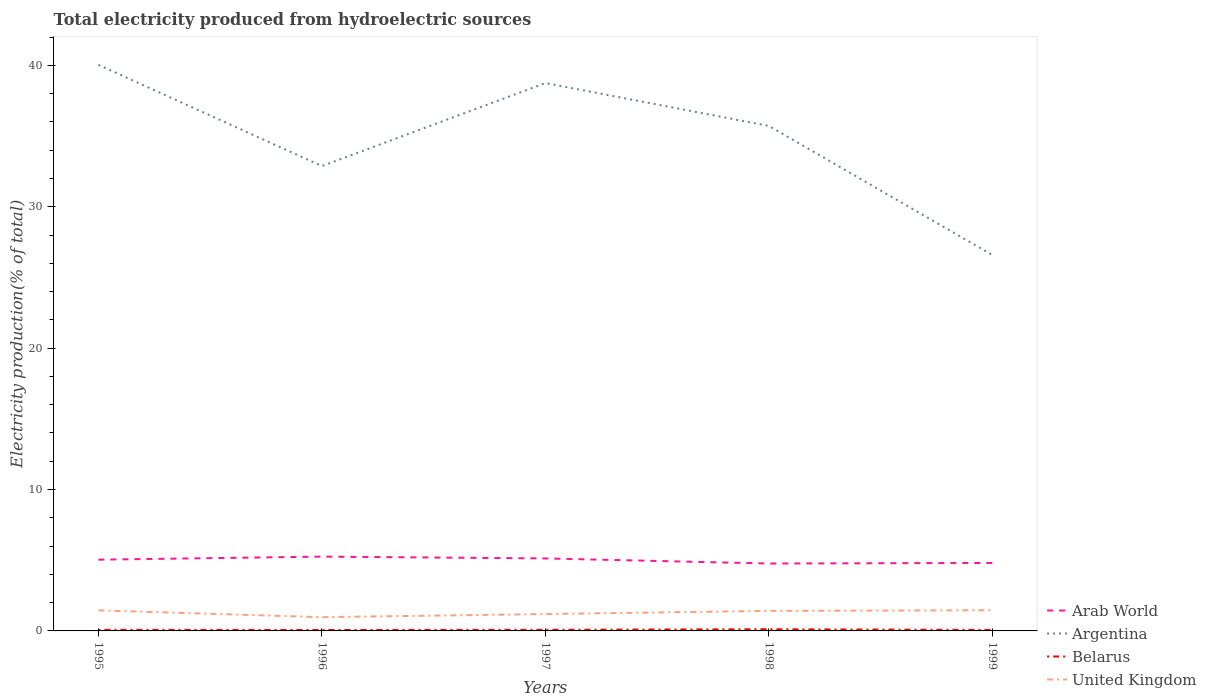How many different coloured lines are there?
Your response must be concise. 4. Across all years, what is the maximum total electricity produced in Arab World?
Your response must be concise. 4.77. What is the total total electricity produced in United Kingdom in the graph?
Your response must be concise. -0.45. What is the difference between the highest and the second highest total electricity produced in Belarus?
Provide a succinct answer. 0.05. What is the difference between the highest and the lowest total electricity produced in Belarus?
Provide a succinct answer. 1. How many lines are there?
Provide a succinct answer. 4. What is the difference between two consecutive major ticks on the Y-axis?
Your answer should be compact. 10. Are the values on the major ticks of Y-axis written in scientific E-notation?
Your answer should be compact. No. Where does the legend appear in the graph?
Provide a short and direct response. Bottom right. How are the legend labels stacked?
Offer a terse response. Vertical. What is the title of the graph?
Offer a terse response. Total electricity produced from hydroelectric sources. What is the label or title of the X-axis?
Your answer should be compact. Years. What is the Electricity production(% of total) in Arab World in 1995?
Your answer should be very brief. 5.04. What is the Electricity production(% of total) of Argentina in 1995?
Provide a succinct answer. 40.04. What is the Electricity production(% of total) of Belarus in 1995?
Provide a short and direct response. 0.08. What is the Electricity production(% of total) of United Kingdom in 1995?
Your response must be concise. 1.46. What is the Electricity production(% of total) of Arab World in 1996?
Make the answer very short. 5.26. What is the Electricity production(% of total) of Argentina in 1996?
Give a very brief answer. 32.88. What is the Electricity production(% of total) of Belarus in 1996?
Provide a short and direct response. 0.07. What is the Electricity production(% of total) of United Kingdom in 1996?
Keep it short and to the point. 0.97. What is the Electricity production(% of total) of Arab World in 1997?
Your response must be concise. 5.13. What is the Electricity production(% of total) in Argentina in 1997?
Make the answer very short. 38.75. What is the Electricity production(% of total) in Belarus in 1997?
Ensure brevity in your answer.  0.08. What is the Electricity production(% of total) in United Kingdom in 1997?
Keep it short and to the point. 1.19. What is the Electricity production(% of total) of Arab World in 1998?
Ensure brevity in your answer.  4.77. What is the Electricity production(% of total) in Argentina in 1998?
Provide a short and direct response. 35.72. What is the Electricity production(% of total) in Belarus in 1998?
Offer a very short reply. 0.12. What is the Electricity production(% of total) in United Kingdom in 1998?
Give a very brief answer. 1.42. What is the Electricity production(% of total) of Arab World in 1999?
Offer a terse response. 4.81. What is the Electricity production(% of total) of Argentina in 1999?
Offer a terse response. 26.58. What is the Electricity production(% of total) of Belarus in 1999?
Ensure brevity in your answer.  0.07. What is the Electricity production(% of total) in United Kingdom in 1999?
Your answer should be compact. 1.46. Across all years, what is the maximum Electricity production(% of total) in Arab World?
Give a very brief answer. 5.26. Across all years, what is the maximum Electricity production(% of total) of Argentina?
Your response must be concise. 40.04. Across all years, what is the maximum Electricity production(% of total) of Belarus?
Give a very brief answer. 0.12. Across all years, what is the maximum Electricity production(% of total) of United Kingdom?
Give a very brief answer. 1.46. Across all years, what is the minimum Electricity production(% of total) of Arab World?
Your answer should be very brief. 4.77. Across all years, what is the minimum Electricity production(% of total) in Argentina?
Ensure brevity in your answer.  26.58. Across all years, what is the minimum Electricity production(% of total) of Belarus?
Your answer should be compact. 0.07. Across all years, what is the minimum Electricity production(% of total) in United Kingdom?
Ensure brevity in your answer.  0.97. What is the total Electricity production(% of total) of Arab World in the graph?
Provide a short and direct response. 25. What is the total Electricity production(% of total) in Argentina in the graph?
Your response must be concise. 173.97. What is the total Electricity production(% of total) of Belarus in the graph?
Ensure brevity in your answer.  0.42. What is the total Electricity production(% of total) of United Kingdom in the graph?
Provide a succinct answer. 6.5. What is the difference between the Electricity production(% of total) of Arab World in 1995 and that in 1996?
Offer a very short reply. -0.22. What is the difference between the Electricity production(% of total) in Argentina in 1995 and that in 1996?
Your response must be concise. 7.16. What is the difference between the Electricity production(% of total) in Belarus in 1995 and that in 1996?
Provide a short and direct response. 0.01. What is the difference between the Electricity production(% of total) in United Kingdom in 1995 and that in 1996?
Your response must be concise. 0.48. What is the difference between the Electricity production(% of total) in Arab World in 1995 and that in 1997?
Make the answer very short. -0.09. What is the difference between the Electricity production(% of total) in Argentina in 1995 and that in 1997?
Ensure brevity in your answer.  1.29. What is the difference between the Electricity production(% of total) of Belarus in 1995 and that in 1997?
Provide a succinct answer. -0. What is the difference between the Electricity production(% of total) of United Kingdom in 1995 and that in 1997?
Ensure brevity in your answer.  0.26. What is the difference between the Electricity production(% of total) in Arab World in 1995 and that in 1998?
Offer a terse response. 0.27. What is the difference between the Electricity production(% of total) of Argentina in 1995 and that in 1998?
Your response must be concise. 4.32. What is the difference between the Electricity production(% of total) of Belarus in 1995 and that in 1998?
Provide a short and direct response. -0.04. What is the difference between the Electricity production(% of total) in United Kingdom in 1995 and that in 1998?
Make the answer very short. 0.04. What is the difference between the Electricity production(% of total) of Arab World in 1995 and that in 1999?
Make the answer very short. 0.23. What is the difference between the Electricity production(% of total) of Argentina in 1995 and that in 1999?
Provide a short and direct response. 13.45. What is the difference between the Electricity production(% of total) in Belarus in 1995 and that in 1999?
Give a very brief answer. 0.01. What is the difference between the Electricity production(% of total) of United Kingdom in 1995 and that in 1999?
Provide a succinct answer. -0.01. What is the difference between the Electricity production(% of total) of Arab World in 1996 and that in 1997?
Provide a succinct answer. 0.13. What is the difference between the Electricity production(% of total) of Argentina in 1996 and that in 1997?
Offer a very short reply. -5.87. What is the difference between the Electricity production(% of total) of Belarus in 1996 and that in 1997?
Make the answer very short. -0.01. What is the difference between the Electricity production(% of total) of United Kingdom in 1996 and that in 1997?
Your response must be concise. -0.22. What is the difference between the Electricity production(% of total) of Arab World in 1996 and that in 1998?
Provide a succinct answer. 0.49. What is the difference between the Electricity production(% of total) of Argentina in 1996 and that in 1998?
Keep it short and to the point. -2.84. What is the difference between the Electricity production(% of total) of Belarus in 1996 and that in 1998?
Provide a succinct answer. -0.05. What is the difference between the Electricity production(% of total) of United Kingdom in 1996 and that in 1998?
Your response must be concise. -0.45. What is the difference between the Electricity production(% of total) of Arab World in 1996 and that in 1999?
Your answer should be compact. 0.45. What is the difference between the Electricity production(% of total) of Argentina in 1996 and that in 1999?
Offer a terse response. 6.29. What is the difference between the Electricity production(% of total) of Belarus in 1996 and that in 1999?
Your response must be concise. -0. What is the difference between the Electricity production(% of total) in United Kingdom in 1996 and that in 1999?
Keep it short and to the point. -0.49. What is the difference between the Electricity production(% of total) in Arab World in 1997 and that in 1998?
Offer a very short reply. 0.36. What is the difference between the Electricity production(% of total) in Argentina in 1997 and that in 1998?
Your answer should be very brief. 3.03. What is the difference between the Electricity production(% of total) of Belarus in 1997 and that in 1998?
Ensure brevity in your answer.  -0.04. What is the difference between the Electricity production(% of total) in United Kingdom in 1997 and that in 1998?
Offer a terse response. -0.22. What is the difference between the Electricity production(% of total) of Arab World in 1997 and that in 1999?
Provide a short and direct response. 0.32. What is the difference between the Electricity production(% of total) of Argentina in 1997 and that in 1999?
Ensure brevity in your answer.  12.16. What is the difference between the Electricity production(% of total) of Belarus in 1997 and that in 1999?
Provide a short and direct response. 0.01. What is the difference between the Electricity production(% of total) in United Kingdom in 1997 and that in 1999?
Keep it short and to the point. -0.27. What is the difference between the Electricity production(% of total) in Arab World in 1998 and that in 1999?
Your response must be concise. -0.04. What is the difference between the Electricity production(% of total) in Argentina in 1998 and that in 1999?
Offer a terse response. 9.13. What is the difference between the Electricity production(% of total) of Belarus in 1998 and that in 1999?
Offer a terse response. 0.05. What is the difference between the Electricity production(% of total) in United Kingdom in 1998 and that in 1999?
Your answer should be very brief. -0.04. What is the difference between the Electricity production(% of total) in Arab World in 1995 and the Electricity production(% of total) in Argentina in 1996?
Ensure brevity in your answer.  -27.84. What is the difference between the Electricity production(% of total) of Arab World in 1995 and the Electricity production(% of total) of Belarus in 1996?
Offer a terse response. 4.97. What is the difference between the Electricity production(% of total) of Arab World in 1995 and the Electricity production(% of total) of United Kingdom in 1996?
Provide a succinct answer. 4.07. What is the difference between the Electricity production(% of total) of Argentina in 1995 and the Electricity production(% of total) of Belarus in 1996?
Give a very brief answer. 39.97. What is the difference between the Electricity production(% of total) in Argentina in 1995 and the Electricity production(% of total) in United Kingdom in 1996?
Your answer should be very brief. 39.07. What is the difference between the Electricity production(% of total) in Belarus in 1995 and the Electricity production(% of total) in United Kingdom in 1996?
Offer a very short reply. -0.89. What is the difference between the Electricity production(% of total) of Arab World in 1995 and the Electricity production(% of total) of Argentina in 1997?
Provide a succinct answer. -33.71. What is the difference between the Electricity production(% of total) in Arab World in 1995 and the Electricity production(% of total) in Belarus in 1997?
Your answer should be very brief. 4.96. What is the difference between the Electricity production(% of total) of Arab World in 1995 and the Electricity production(% of total) of United Kingdom in 1997?
Give a very brief answer. 3.85. What is the difference between the Electricity production(% of total) of Argentina in 1995 and the Electricity production(% of total) of Belarus in 1997?
Your answer should be very brief. 39.96. What is the difference between the Electricity production(% of total) in Argentina in 1995 and the Electricity production(% of total) in United Kingdom in 1997?
Provide a short and direct response. 38.84. What is the difference between the Electricity production(% of total) of Belarus in 1995 and the Electricity production(% of total) of United Kingdom in 1997?
Your answer should be very brief. -1.11. What is the difference between the Electricity production(% of total) of Arab World in 1995 and the Electricity production(% of total) of Argentina in 1998?
Keep it short and to the point. -30.68. What is the difference between the Electricity production(% of total) of Arab World in 1995 and the Electricity production(% of total) of Belarus in 1998?
Make the answer very short. 4.92. What is the difference between the Electricity production(% of total) of Arab World in 1995 and the Electricity production(% of total) of United Kingdom in 1998?
Keep it short and to the point. 3.62. What is the difference between the Electricity production(% of total) in Argentina in 1995 and the Electricity production(% of total) in Belarus in 1998?
Make the answer very short. 39.92. What is the difference between the Electricity production(% of total) of Argentina in 1995 and the Electricity production(% of total) of United Kingdom in 1998?
Provide a short and direct response. 38.62. What is the difference between the Electricity production(% of total) in Belarus in 1995 and the Electricity production(% of total) in United Kingdom in 1998?
Keep it short and to the point. -1.34. What is the difference between the Electricity production(% of total) of Arab World in 1995 and the Electricity production(% of total) of Argentina in 1999?
Your answer should be very brief. -21.55. What is the difference between the Electricity production(% of total) of Arab World in 1995 and the Electricity production(% of total) of Belarus in 1999?
Your response must be concise. 4.97. What is the difference between the Electricity production(% of total) in Arab World in 1995 and the Electricity production(% of total) in United Kingdom in 1999?
Your answer should be very brief. 3.58. What is the difference between the Electricity production(% of total) in Argentina in 1995 and the Electricity production(% of total) in Belarus in 1999?
Offer a terse response. 39.97. What is the difference between the Electricity production(% of total) of Argentina in 1995 and the Electricity production(% of total) of United Kingdom in 1999?
Ensure brevity in your answer.  38.58. What is the difference between the Electricity production(% of total) of Belarus in 1995 and the Electricity production(% of total) of United Kingdom in 1999?
Your response must be concise. -1.38. What is the difference between the Electricity production(% of total) in Arab World in 1996 and the Electricity production(% of total) in Argentina in 1997?
Make the answer very short. -33.49. What is the difference between the Electricity production(% of total) of Arab World in 1996 and the Electricity production(% of total) of Belarus in 1997?
Offer a terse response. 5.18. What is the difference between the Electricity production(% of total) in Arab World in 1996 and the Electricity production(% of total) in United Kingdom in 1997?
Provide a succinct answer. 4.06. What is the difference between the Electricity production(% of total) of Argentina in 1996 and the Electricity production(% of total) of Belarus in 1997?
Make the answer very short. 32.8. What is the difference between the Electricity production(% of total) of Argentina in 1996 and the Electricity production(% of total) of United Kingdom in 1997?
Your answer should be very brief. 31.68. What is the difference between the Electricity production(% of total) in Belarus in 1996 and the Electricity production(% of total) in United Kingdom in 1997?
Offer a very short reply. -1.13. What is the difference between the Electricity production(% of total) in Arab World in 1996 and the Electricity production(% of total) in Argentina in 1998?
Offer a terse response. -30.46. What is the difference between the Electricity production(% of total) in Arab World in 1996 and the Electricity production(% of total) in Belarus in 1998?
Your answer should be very brief. 5.14. What is the difference between the Electricity production(% of total) in Arab World in 1996 and the Electricity production(% of total) in United Kingdom in 1998?
Provide a short and direct response. 3.84. What is the difference between the Electricity production(% of total) in Argentina in 1996 and the Electricity production(% of total) in Belarus in 1998?
Give a very brief answer. 32.76. What is the difference between the Electricity production(% of total) of Argentina in 1996 and the Electricity production(% of total) of United Kingdom in 1998?
Keep it short and to the point. 31.46. What is the difference between the Electricity production(% of total) of Belarus in 1996 and the Electricity production(% of total) of United Kingdom in 1998?
Offer a terse response. -1.35. What is the difference between the Electricity production(% of total) in Arab World in 1996 and the Electricity production(% of total) in Argentina in 1999?
Your answer should be compact. -21.33. What is the difference between the Electricity production(% of total) in Arab World in 1996 and the Electricity production(% of total) in Belarus in 1999?
Make the answer very short. 5.18. What is the difference between the Electricity production(% of total) in Arab World in 1996 and the Electricity production(% of total) in United Kingdom in 1999?
Offer a very short reply. 3.8. What is the difference between the Electricity production(% of total) of Argentina in 1996 and the Electricity production(% of total) of Belarus in 1999?
Your answer should be very brief. 32.81. What is the difference between the Electricity production(% of total) in Argentina in 1996 and the Electricity production(% of total) in United Kingdom in 1999?
Give a very brief answer. 31.42. What is the difference between the Electricity production(% of total) in Belarus in 1996 and the Electricity production(% of total) in United Kingdom in 1999?
Provide a short and direct response. -1.39. What is the difference between the Electricity production(% of total) in Arab World in 1997 and the Electricity production(% of total) in Argentina in 1998?
Your answer should be very brief. -30.59. What is the difference between the Electricity production(% of total) in Arab World in 1997 and the Electricity production(% of total) in Belarus in 1998?
Make the answer very short. 5.01. What is the difference between the Electricity production(% of total) in Arab World in 1997 and the Electricity production(% of total) in United Kingdom in 1998?
Your response must be concise. 3.71. What is the difference between the Electricity production(% of total) of Argentina in 1997 and the Electricity production(% of total) of Belarus in 1998?
Provide a short and direct response. 38.63. What is the difference between the Electricity production(% of total) in Argentina in 1997 and the Electricity production(% of total) in United Kingdom in 1998?
Provide a succinct answer. 37.33. What is the difference between the Electricity production(% of total) in Belarus in 1997 and the Electricity production(% of total) in United Kingdom in 1998?
Your response must be concise. -1.34. What is the difference between the Electricity production(% of total) of Arab World in 1997 and the Electricity production(% of total) of Argentina in 1999?
Your answer should be very brief. -21.46. What is the difference between the Electricity production(% of total) in Arab World in 1997 and the Electricity production(% of total) in Belarus in 1999?
Offer a very short reply. 5.06. What is the difference between the Electricity production(% of total) in Arab World in 1997 and the Electricity production(% of total) in United Kingdom in 1999?
Keep it short and to the point. 3.67. What is the difference between the Electricity production(% of total) of Argentina in 1997 and the Electricity production(% of total) of Belarus in 1999?
Offer a terse response. 38.68. What is the difference between the Electricity production(% of total) in Argentina in 1997 and the Electricity production(% of total) in United Kingdom in 1999?
Make the answer very short. 37.29. What is the difference between the Electricity production(% of total) in Belarus in 1997 and the Electricity production(% of total) in United Kingdom in 1999?
Offer a very short reply. -1.38. What is the difference between the Electricity production(% of total) of Arab World in 1998 and the Electricity production(% of total) of Argentina in 1999?
Provide a succinct answer. -21.82. What is the difference between the Electricity production(% of total) of Arab World in 1998 and the Electricity production(% of total) of Belarus in 1999?
Keep it short and to the point. 4.7. What is the difference between the Electricity production(% of total) of Arab World in 1998 and the Electricity production(% of total) of United Kingdom in 1999?
Provide a succinct answer. 3.31. What is the difference between the Electricity production(% of total) of Argentina in 1998 and the Electricity production(% of total) of Belarus in 1999?
Make the answer very short. 35.65. What is the difference between the Electricity production(% of total) in Argentina in 1998 and the Electricity production(% of total) in United Kingdom in 1999?
Ensure brevity in your answer.  34.26. What is the difference between the Electricity production(% of total) in Belarus in 1998 and the Electricity production(% of total) in United Kingdom in 1999?
Offer a terse response. -1.34. What is the average Electricity production(% of total) of Arab World per year?
Offer a very short reply. 5. What is the average Electricity production(% of total) of Argentina per year?
Ensure brevity in your answer.  34.79. What is the average Electricity production(% of total) in Belarus per year?
Ensure brevity in your answer.  0.08. What is the average Electricity production(% of total) in United Kingdom per year?
Provide a short and direct response. 1.3. In the year 1995, what is the difference between the Electricity production(% of total) in Arab World and Electricity production(% of total) in Argentina?
Offer a terse response. -35. In the year 1995, what is the difference between the Electricity production(% of total) in Arab World and Electricity production(% of total) in Belarus?
Your answer should be compact. 4.96. In the year 1995, what is the difference between the Electricity production(% of total) in Arab World and Electricity production(% of total) in United Kingdom?
Make the answer very short. 3.58. In the year 1995, what is the difference between the Electricity production(% of total) in Argentina and Electricity production(% of total) in Belarus?
Ensure brevity in your answer.  39.96. In the year 1995, what is the difference between the Electricity production(% of total) in Argentina and Electricity production(% of total) in United Kingdom?
Make the answer very short. 38.58. In the year 1995, what is the difference between the Electricity production(% of total) in Belarus and Electricity production(% of total) in United Kingdom?
Offer a very short reply. -1.37. In the year 1996, what is the difference between the Electricity production(% of total) in Arab World and Electricity production(% of total) in Argentina?
Provide a succinct answer. -27.62. In the year 1996, what is the difference between the Electricity production(% of total) of Arab World and Electricity production(% of total) of Belarus?
Offer a terse response. 5.19. In the year 1996, what is the difference between the Electricity production(% of total) of Arab World and Electricity production(% of total) of United Kingdom?
Your answer should be very brief. 4.28. In the year 1996, what is the difference between the Electricity production(% of total) in Argentina and Electricity production(% of total) in Belarus?
Make the answer very short. 32.81. In the year 1996, what is the difference between the Electricity production(% of total) of Argentina and Electricity production(% of total) of United Kingdom?
Ensure brevity in your answer.  31.91. In the year 1996, what is the difference between the Electricity production(% of total) in Belarus and Electricity production(% of total) in United Kingdom?
Your response must be concise. -0.9. In the year 1997, what is the difference between the Electricity production(% of total) in Arab World and Electricity production(% of total) in Argentina?
Make the answer very short. -33.62. In the year 1997, what is the difference between the Electricity production(% of total) in Arab World and Electricity production(% of total) in Belarus?
Provide a succinct answer. 5.05. In the year 1997, what is the difference between the Electricity production(% of total) in Arab World and Electricity production(% of total) in United Kingdom?
Your answer should be compact. 3.93. In the year 1997, what is the difference between the Electricity production(% of total) in Argentina and Electricity production(% of total) in Belarus?
Keep it short and to the point. 38.67. In the year 1997, what is the difference between the Electricity production(% of total) in Argentina and Electricity production(% of total) in United Kingdom?
Keep it short and to the point. 37.56. In the year 1997, what is the difference between the Electricity production(% of total) in Belarus and Electricity production(% of total) in United Kingdom?
Make the answer very short. -1.11. In the year 1998, what is the difference between the Electricity production(% of total) in Arab World and Electricity production(% of total) in Argentina?
Make the answer very short. -30.95. In the year 1998, what is the difference between the Electricity production(% of total) in Arab World and Electricity production(% of total) in Belarus?
Ensure brevity in your answer.  4.65. In the year 1998, what is the difference between the Electricity production(% of total) of Arab World and Electricity production(% of total) of United Kingdom?
Your answer should be compact. 3.35. In the year 1998, what is the difference between the Electricity production(% of total) of Argentina and Electricity production(% of total) of Belarus?
Offer a terse response. 35.6. In the year 1998, what is the difference between the Electricity production(% of total) of Argentina and Electricity production(% of total) of United Kingdom?
Ensure brevity in your answer.  34.3. In the year 1998, what is the difference between the Electricity production(% of total) in Belarus and Electricity production(% of total) in United Kingdom?
Make the answer very short. -1.3. In the year 1999, what is the difference between the Electricity production(% of total) in Arab World and Electricity production(% of total) in Argentina?
Your response must be concise. -21.78. In the year 1999, what is the difference between the Electricity production(% of total) of Arab World and Electricity production(% of total) of Belarus?
Provide a succinct answer. 4.73. In the year 1999, what is the difference between the Electricity production(% of total) of Arab World and Electricity production(% of total) of United Kingdom?
Your answer should be very brief. 3.35. In the year 1999, what is the difference between the Electricity production(% of total) in Argentina and Electricity production(% of total) in Belarus?
Offer a terse response. 26.51. In the year 1999, what is the difference between the Electricity production(% of total) in Argentina and Electricity production(% of total) in United Kingdom?
Keep it short and to the point. 25.12. In the year 1999, what is the difference between the Electricity production(% of total) of Belarus and Electricity production(% of total) of United Kingdom?
Your answer should be compact. -1.39. What is the ratio of the Electricity production(% of total) of Arab World in 1995 to that in 1996?
Make the answer very short. 0.96. What is the ratio of the Electricity production(% of total) of Argentina in 1995 to that in 1996?
Provide a short and direct response. 1.22. What is the ratio of the Electricity production(% of total) of Belarus in 1995 to that in 1996?
Provide a succinct answer. 1.19. What is the ratio of the Electricity production(% of total) in United Kingdom in 1995 to that in 1996?
Offer a terse response. 1.5. What is the ratio of the Electricity production(% of total) in Arab World in 1995 to that in 1997?
Give a very brief answer. 0.98. What is the ratio of the Electricity production(% of total) in Argentina in 1995 to that in 1997?
Offer a terse response. 1.03. What is the ratio of the Electricity production(% of total) in Belarus in 1995 to that in 1997?
Offer a terse response. 1. What is the ratio of the Electricity production(% of total) of United Kingdom in 1995 to that in 1997?
Give a very brief answer. 1.22. What is the ratio of the Electricity production(% of total) of Arab World in 1995 to that in 1998?
Provide a short and direct response. 1.06. What is the ratio of the Electricity production(% of total) of Argentina in 1995 to that in 1998?
Offer a terse response. 1.12. What is the ratio of the Electricity production(% of total) in Belarus in 1995 to that in 1998?
Provide a succinct answer. 0.67. What is the ratio of the Electricity production(% of total) of United Kingdom in 1995 to that in 1998?
Your response must be concise. 1.03. What is the ratio of the Electricity production(% of total) in Arab World in 1995 to that in 1999?
Provide a succinct answer. 1.05. What is the ratio of the Electricity production(% of total) of Argentina in 1995 to that in 1999?
Offer a terse response. 1.51. What is the ratio of the Electricity production(% of total) in Belarus in 1995 to that in 1999?
Ensure brevity in your answer.  1.12. What is the ratio of the Electricity production(% of total) of United Kingdom in 1995 to that in 1999?
Keep it short and to the point. 1. What is the ratio of the Electricity production(% of total) of Arab World in 1996 to that in 1997?
Make the answer very short. 1.03. What is the ratio of the Electricity production(% of total) of Argentina in 1996 to that in 1997?
Your answer should be compact. 0.85. What is the ratio of the Electricity production(% of total) of Belarus in 1996 to that in 1997?
Provide a succinct answer. 0.84. What is the ratio of the Electricity production(% of total) of United Kingdom in 1996 to that in 1997?
Your answer should be compact. 0.81. What is the ratio of the Electricity production(% of total) of Arab World in 1996 to that in 1998?
Keep it short and to the point. 1.1. What is the ratio of the Electricity production(% of total) in Argentina in 1996 to that in 1998?
Offer a very short reply. 0.92. What is the ratio of the Electricity production(% of total) in Belarus in 1996 to that in 1998?
Your answer should be compact. 0.57. What is the ratio of the Electricity production(% of total) of United Kingdom in 1996 to that in 1998?
Ensure brevity in your answer.  0.69. What is the ratio of the Electricity production(% of total) in Arab World in 1996 to that in 1999?
Your answer should be very brief. 1.09. What is the ratio of the Electricity production(% of total) of Argentina in 1996 to that in 1999?
Provide a short and direct response. 1.24. What is the ratio of the Electricity production(% of total) in Belarus in 1996 to that in 1999?
Provide a succinct answer. 0.94. What is the ratio of the Electricity production(% of total) of United Kingdom in 1996 to that in 1999?
Give a very brief answer. 0.66. What is the ratio of the Electricity production(% of total) of Arab World in 1997 to that in 1998?
Offer a terse response. 1.08. What is the ratio of the Electricity production(% of total) in Argentina in 1997 to that in 1998?
Keep it short and to the point. 1.08. What is the ratio of the Electricity production(% of total) in Belarus in 1997 to that in 1998?
Provide a short and direct response. 0.68. What is the ratio of the Electricity production(% of total) in United Kingdom in 1997 to that in 1998?
Keep it short and to the point. 0.84. What is the ratio of the Electricity production(% of total) of Arab World in 1997 to that in 1999?
Provide a short and direct response. 1.07. What is the ratio of the Electricity production(% of total) in Argentina in 1997 to that in 1999?
Your answer should be very brief. 1.46. What is the ratio of the Electricity production(% of total) of Belarus in 1997 to that in 1999?
Offer a terse response. 1.12. What is the ratio of the Electricity production(% of total) of United Kingdom in 1997 to that in 1999?
Provide a succinct answer. 0.82. What is the ratio of the Electricity production(% of total) in Arab World in 1998 to that in 1999?
Provide a succinct answer. 0.99. What is the ratio of the Electricity production(% of total) of Argentina in 1998 to that in 1999?
Your response must be concise. 1.34. What is the ratio of the Electricity production(% of total) of Belarus in 1998 to that in 1999?
Provide a short and direct response. 1.66. What is the ratio of the Electricity production(% of total) of United Kingdom in 1998 to that in 1999?
Your answer should be compact. 0.97. What is the difference between the highest and the second highest Electricity production(% of total) of Arab World?
Provide a short and direct response. 0.13. What is the difference between the highest and the second highest Electricity production(% of total) in Argentina?
Offer a terse response. 1.29. What is the difference between the highest and the second highest Electricity production(% of total) in Belarus?
Provide a short and direct response. 0.04. What is the difference between the highest and the second highest Electricity production(% of total) in United Kingdom?
Give a very brief answer. 0.01. What is the difference between the highest and the lowest Electricity production(% of total) in Arab World?
Provide a succinct answer. 0.49. What is the difference between the highest and the lowest Electricity production(% of total) of Argentina?
Provide a short and direct response. 13.45. What is the difference between the highest and the lowest Electricity production(% of total) of Belarus?
Make the answer very short. 0.05. What is the difference between the highest and the lowest Electricity production(% of total) of United Kingdom?
Offer a very short reply. 0.49. 